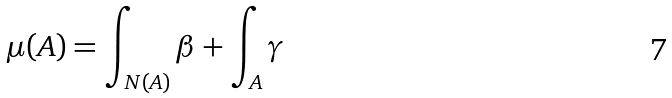Convert formula to latex. <formula><loc_0><loc_0><loc_500><loc_500>\mu ( A ) = \int _ { N ( A ) } \beta + \int _ { A } \gamma</formula> 